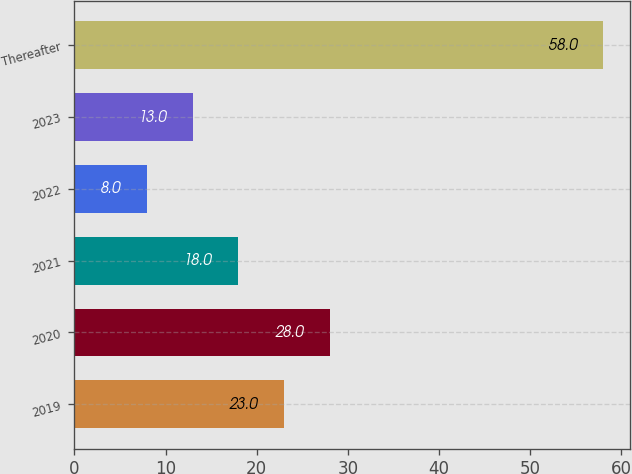Convert chart to OTSL. <chart><loc_0><loc_0><loc_500><loc_500><bar_chart><fcel>2019<fcel>2020<fcel>2021<fcel>2022<fcel>2023<fcel>Thereafter<nl><fcel>23<fcel>28<fcel>18<fcel>8<fcel>13<fcel>58<nl></chart> 